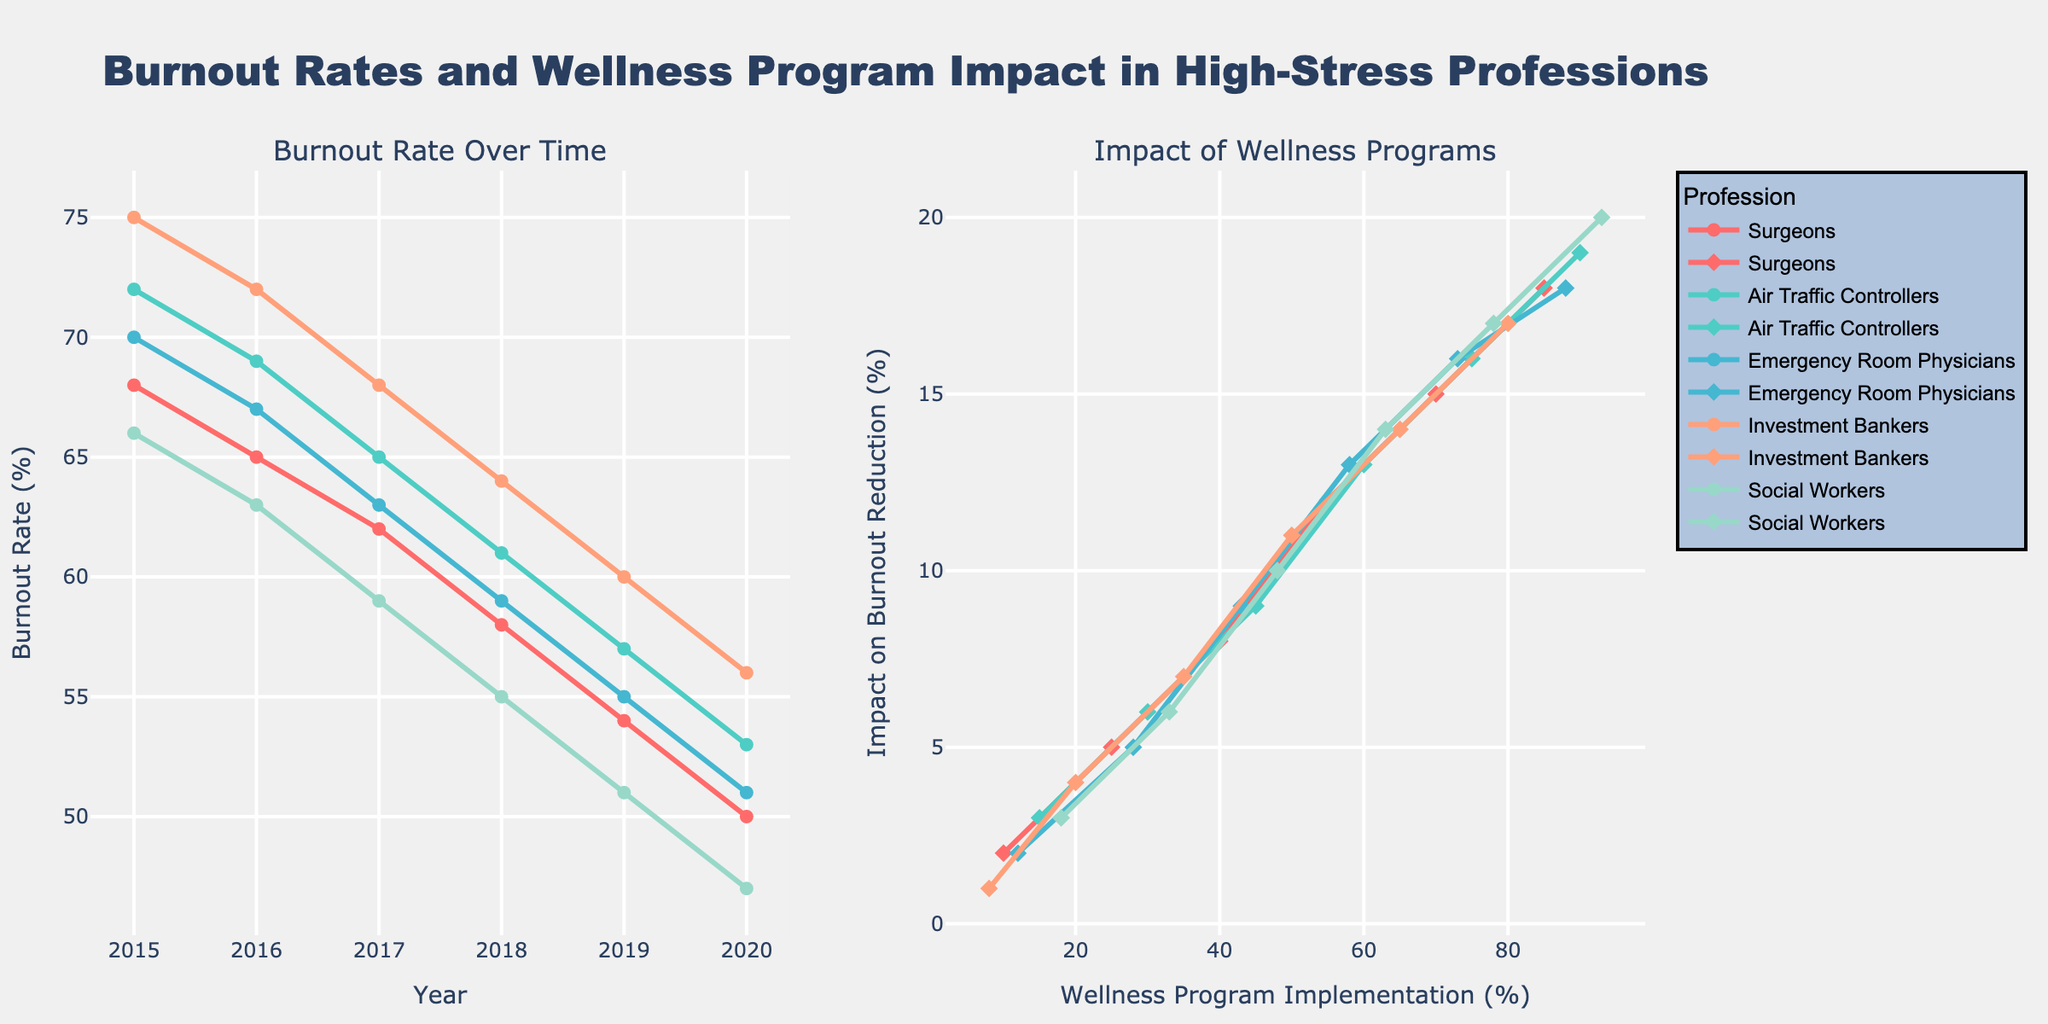What was the burnout rate for Surgeons in 2020? Look at the line corresponding to Surgeons on the "Burnout Rate Over Time" plot. The burnout rate value for 2020 can be read directly from the y-axis.
Answer: 50% Which profession had the highest burnout rate in 2015? Review the starting points for each line on the "Burnout Rate Over Time" plot. The profession with the highest y-value in 2015 has the highest burnout rate.
Answer: Investment Bankers Which profession shows the greatest reduction in burnout rate over the observed period? Compare the y-axis differences from 2015 to 2020 for each profession on the "Burnout Rate Over Time" plot. The profession with the largest drop has the greatest reduction.
Answer: Social Workers In what year did Air Traffic Controllers see a burnout rate below 60%? Follow the line for Air Traffic Controllers on the "Burnout Rate Over Time" plot and identify the year when it first drops below the 60% y-value.
Answer: 2018 How does the effectiveness of wellness programs compare between Emergency Room Physicians and Social Workers in 2020? Look at the points on the "Impact of Wellness Programs" plot for both Emergency Room Physicians and Social Workers in 2020. Compare their y-values.
Answer: Social Workers have a higher impact What was the most significant year-to-year drop in burnout rate for Investment Bankers? Inspect the "Burnout Rate Over Time" plot for Investment Bankers and identify the largest vertical drop between any two consecutive years.
Answer: 2017 to 2018 Which profession achieved an 85% wellness program implementation first? On the "Impact of Wellness Programs" plot, find the first 85% x-value and determine which profession’s line achieves it first.
Answer: Surgeons Between 2015 and 2020, which year saw the smallest improvement in burnout reduction for Surgeons? Analyze the curve on the "Burnout Rate Over Time" plot for Surgeons and determine which year-to-year gap is the smallest.
Answer: 2015 to 2016 What is the average burnout rate for Emergency Room Physicians from 2018 to 2020? Average the y-values for Emergency Room Physicians on the "Burnout Rate Over Time" plot for the years 2018, 2019, and 2020. Calculation: (59 + 55 + 51)/3
Answer: 55% How much did the wellness program impact on burnout reduction increase for Air Traffic Controllers from 2015 to 2020? Determine the y-values for Air Traffic Controllers on the "Impact of Wellness Programs" plot for 2015 and 2020, then calculate the difference. Calculation: 19% - 3%
Answer: 16% 